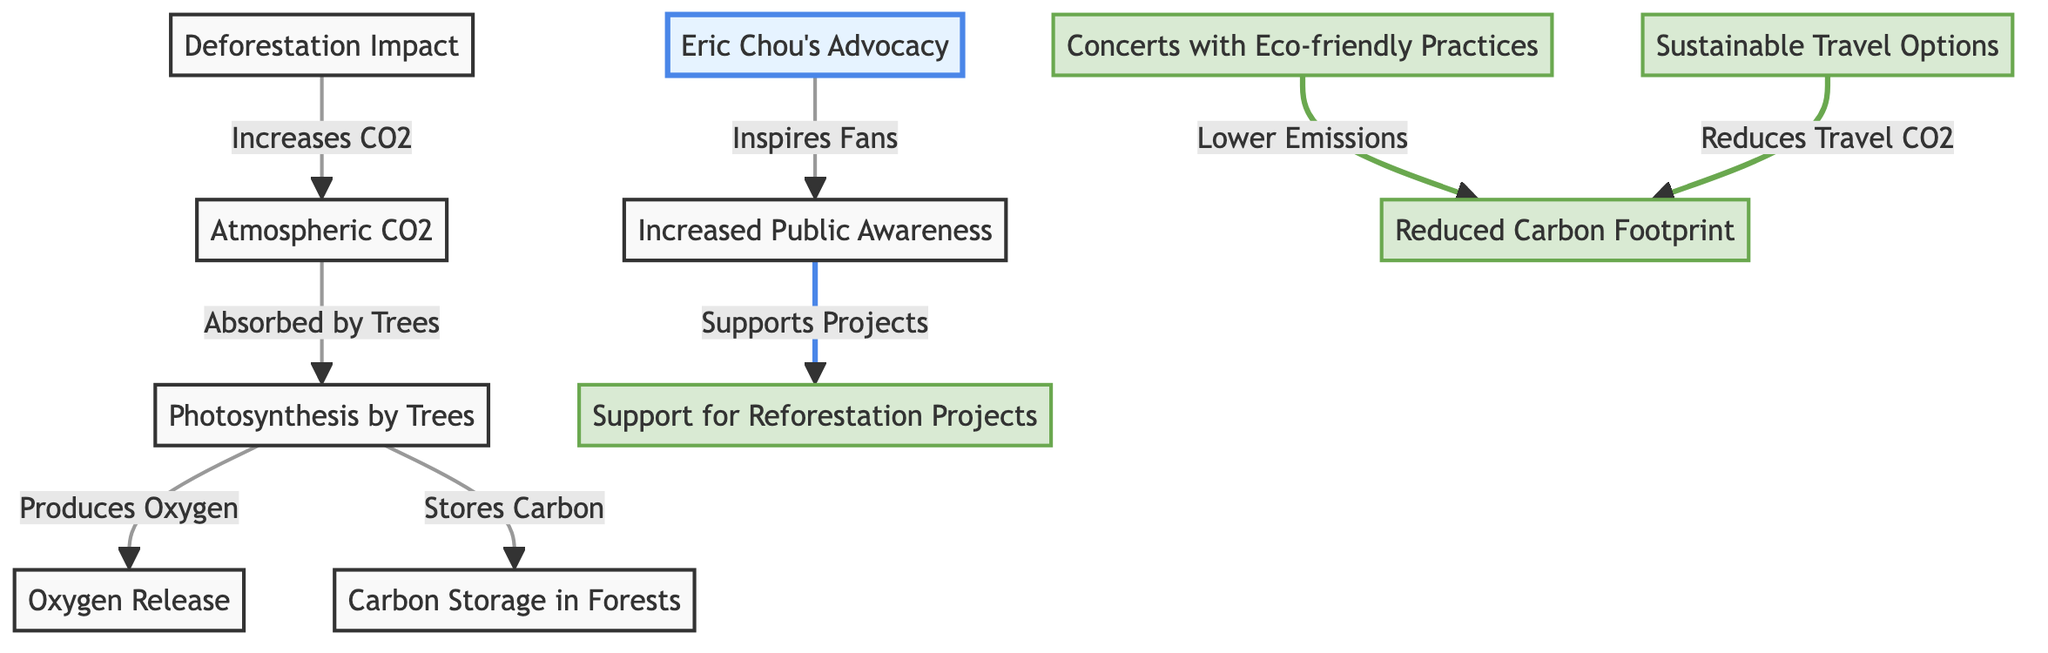What is the first node in the diagram? The first node represents "Atmospheric CO2," which serves as the starting point for the carbon cycle in this diagram.
Answer: Atmospheric CO2 How many nodes are related to Eric Chou's advocacy? There are four nodes that are related to Eric Chou's advocacy: "Eric Chou's Advocacy," "Increased Public Awareness," "Support for Reforestation Projects," and "Concerts with Eco-friendly Practices."
Answer: Four What does photosynthesis by trees produce? Photosynthesis by trees produces "Oxygen," as indicated in the connection between the nodes for "Photosynthesis by Trees" and "Oxygen Release."
Answer: Oxygen Which node represents the impact of deforestation? The node that represents the impact of deforestation is labeled "Deforestation Impact." This is linked to the increase of CO2 in the atmosphere.
Answer: Deforestation Impact What is the relationship between "Increased Public Awareness" and "Support for Reforestation Projects"? "Increased Public Awareness" leads to "Support for Reforestation Projects," indicating that when public awareness increases, it supports reforestation initiatives.
Answer: Leads to What reduction is associated with "Concerts with Eco-friendly Practices"? Concerts with eco-friendly practices are associated with a "Reduced Carbon Footprint," demonstrating how eco-friendly concert practices contribute to lowering carbon emissions.
Answer: Reduced Carbon Footprint How does Eric Chou inspire his fans? Eric Chou inspires his fans through "Advocacy," which connects to the node for "Increased Public Awareness," showing a link between his activities and raising awareness about environmental issues.
Answer: Advocacy What node indicates lower emissions from travel options? The node that indicates lower emissions from travel options is labeled "Sustainable Travel Options," which is linked to the "Reduced Carbon Footprint" node.
Answer: Sustainable Travel Options What process absorbs atmospheric CO2? The process that absorbs atmospheric CO2 is "Photosynthesis by Trees," as shown in the diagram where CO2 flows into this process for absorption.
Answer: Photosynthesis by Trees 